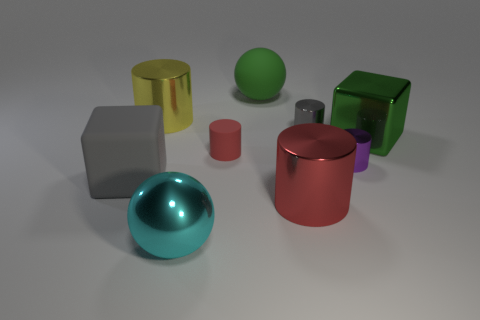Subtract all matte cylinders. How many cylinders are left? 4 Subtract all cylinders. How many objects are left? 4 Subtract all yellow cylinders. How many cylinders are left? 4 Add 7 yellow metal cylinders. How many yellow metal cylinders exist? 8 Subtract 1 gray cylinders. How many objects are left? 8 Subtract 1 cubes. How many cubes are left? 1 Subtract all red cylinders. Subtract all purple cubes. How many cylinders are left? 3 Subtract all green balls. How many yellow cylinders are left? 1 Subtract all large gray things. Subtract all cyan metal objects. How many objects are left? 7 Add 2 red things. How many red things are left? 4 